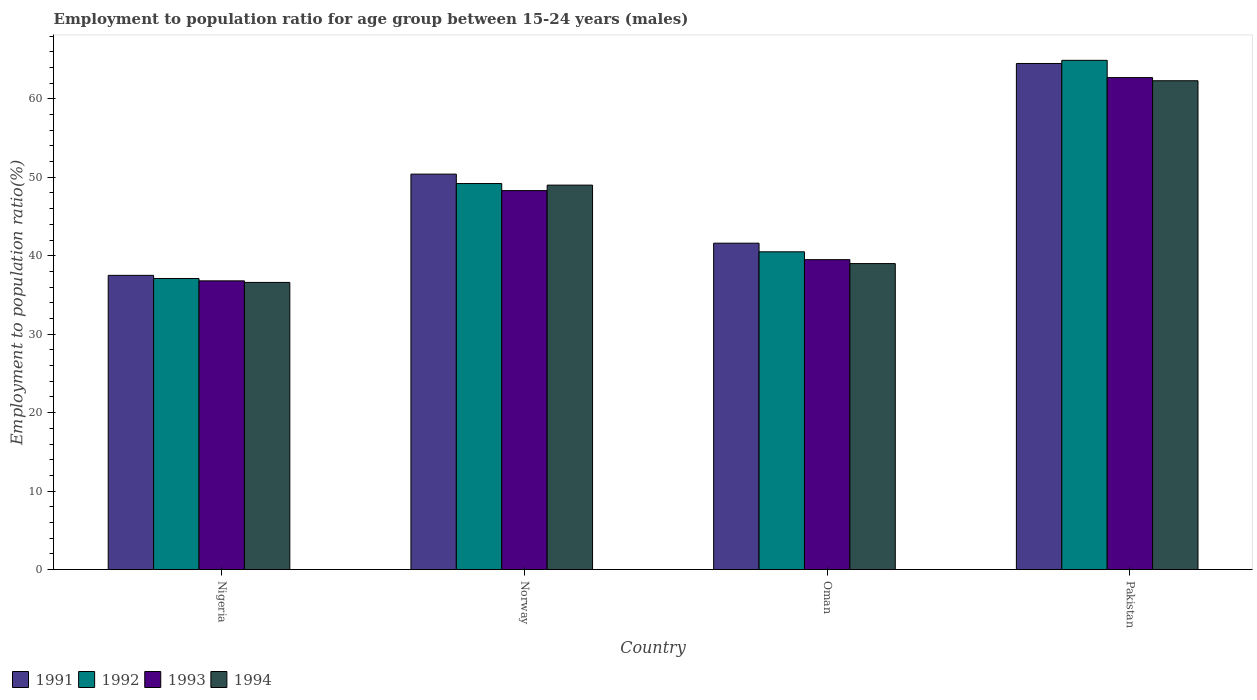How many groups of bars are there?
Your response must be concise. 4. Are the number of bars per tick equal to the number of legend labels?
Provide a succinct answer. Yes. Are the number of bars on each tick of the X-axis equal?
Offer a very short reply. Yes. How many bars are there on the 2nd tick from the left?
Offer a very short reply. 4. How many bars are there on the 3rd tick from the right?
Provide a short and direct response. 4. What is the label of the 3rd group of bars from the left?
Your answer should be compact. Oman. In how many cases, is the number of bars for a given country not equal to the number of legend labels?
Your response must be concise. 0. What is the employment to population ratio in 1991 in Norway?
Your answer should be compact. 50.4. Across all countries, what is the maximum employment to population ratio in 1992?
Your answer should be very brief. 64.9. Across all countries, what is the minimum employment to population ratio in 1991?
Your answer should be very brief. 37.5. In which country was the employment to population ratio in 1991 minimum?
Provide a short and direct response. Nigeria. What is the total employment to population ratio in 1993 in the graph?
Offer a terse response. 187.3. What is the difference between the employment to population ratio in 1992 in Pakistan and the employment to population ratio in 1993 in Oman?
Make the answer very short. 25.4. What is the average employment to population ratio in 1993 per country?
Make the answer very short. 46.82. What is the difference between the employment to population ratio of/in 1994 and employment to population ratio of/in 1993 in Pakistan?
Provide a succinct answer. -0.4. What is the ratio of the employment to population ratio in 1992 in Nigeria to that in Oman?
Provide a short and direct response. 0.92. What is the difference between the highest and the second highest employment to population ratio in 1991?
Provide a short and direct response. 22.9. What is the difference between the highest and the lowest employment to population ratio in 1994?
Give a very brief answer. 25.7. In how many countries, is the employment to population ratio in 1992 greater than the average employment to population ratio in 1992 taken over all countries?
Your answer should be compact. 2. What does the 1st bar from the left in Nigeria represents?
Make the answer very short. 1991. How many bars are there?
Your answer should be compact. 16. Are all the bars in the graph horizontal?
Offer a terse response. No. How many countries are there in the graph?
Your answer should be compact. 4. Are the values on the major ticks of Y-axis written in scientific E-notation?
Ensure brevity in your answer.  No. How are the legend labels stacked?
Provide a short and direct response. Horizontal. What is the title of the graph?
Ensure brevity in your answer.  Employment to population ratio for age group between 15-24 years (males). Does "1999" appear as one of the legend labels in the graph?
Offer a very short reply. No. What is the label or title of the X-axis?
Offer a terse response. Country. What is the Employment to population ratio(%) of 1991 in Nigeria?
Provide a succinct answer. 37.5. What is the Employment to population ratio(%) in 1992 in Nigeria?
Provide a succinct answer. 37.1. What is the Employment to population ratio(%) of 1993 in Nigeria?
Keep it short and to the point. 36.8. What is the Employment to population ratio(%) in 1994 in Nigeria?
Ensure brevity in your answer.  36.6. What is the Employment to population ratio(%) in 1991 in Norway?
Keep it short and to the point. 50.4. What is the Employment to population ratio(%) in 1992 in Norway?
Your answer should be compact. 49.2. What is the Employment to population ratio(%) in 1993 in Norway?
Provide a short and direct response. 48.3. What is the Employment to population ratio(%) in 1991 in Oman?
Provide a short and direct response. 41.6. What is the Employment to population ratio(%) in 1992 in Oman?
Your response must be concise. 40.5. What is the Employment to population ratio(%) of 1993 in Oman?
Give a very brief answer. 39.5. What is the Employment to population ratio(%) in 1991 in Pakistan?
Your answer should be very brief. 64.5. What is the Employment to population ratio(%) in 1992 in Pakistan?
Provide a succinct answer. 64.9. What is the Employment to population ratio(%) in 1993 in Pakistan?
Offer a very short reply. 62.7. What is the Employment to population ratio(%) in 1994 in Pakistan?
Your answer should be compact. 62.3. Across all countries, what is the maximum Employment to population ratio(%) of 1991?
Give a very brief answer. 64.5. Across all countries, what is the maximum Employment to population ratio(%) of 1992?
Make the answer very short. 64.9. Across all countries, what is the maximum Employment to population ratio(%) of 1993?
Your answer should be compact. 62.7. Across all countries, what is the maximum Employment to population ratio(%) in 1994?
Keep it short and to the point. 62.3. Across all countries, what is the minimum Employment to population ratio(%) in 1991?
Keep it short and to the point. 37.5. Across all countries, what is the minimum Employment to population ratio(%) of 1992?
Your answer should be compact. 37.1. Across all countries, what is the minimum Employment to population ratio(%) in 1993?
Offer a terse response. 36.8. Across all countries, what is the minimum Employment to population ratio(%) in 1994?
Your answer should be very brief. 36.6. What is the total Employment to population ratio(%) in 1991 in the graph?
Provide a short and direct response. 194. What is the total Employment to population ratio(%) in 1992 in the graph?
Offer a terse response. 191.7. What is the total Employment to population ratio(%) of 1993 in the graph?
Make the answer very short. 187.3. What is the total Employment to population ratio(%) in 1994 in the graph?
Your response must be concise. 186.9. What is the difference between the Employment to population ratio(%) of 1991 in Nigeria and that in Norway?
Your response must be concise. -12.9. What is the difference between the Employment to population ratio(%) of 1992 in Nigeria and that in Norway?
Offer a very short reply. -12.1. What is the difference between the Employment to population ratio(%) in 1992 in Nigeria and that in Oman?
Offer a terse response. -3.4. What is the difference between the Employment to population ratio(%) of 1992 in Nigeria and that in Pakistan?
Provide a succinct answer. -27.8. What is the difference between the Employment to population ratio(%) of 1993 in Nigeria and that in Pakistan?
Provide a short and direct response. -25.9. What is the difference between the Employment to population ratio(%) in 1994 in Nigeria and that in Pakistan?
Offer a very short reply. -25.7. What is the difference between the Employment to population ratio(%) in 1994 in Norway and that in Oman?
Your answer should be very brief. 10. What is the difference between the Employment to population ratio(%) of 1991 in Norway and that in Pakistan?
Give a very brief answer. -14.1. What is the difference between the Employment to population ratio(%) in 1992 in Norway and that in Pakistan?
Provide a short and direct response. -15.7. What is the difference between the Employment to population ratio(%) in 1993 in Norway and that in Pakistan?
Your answer should be compact. -14.4. What is the difference between the Employment to population ratio(%) of 1991 in Oman and that in Pakistan?
Your answer should be compact. -22.9. What is the difference between the Employment to population ratio(%) in 1992 in Oman and that in Pakistan?
Make the answer very short. -24.4. What is the difference between the Employment to population ratio(%) in 1993 in Oman and that in Pakistan?
Your answer should be compact. -23.2. What is the difference between the Employment to population ratio(%) of 1994 in Oman and that in Pakistan?
Give a very brief answer. -23.3. What is the difference between the Employment to population ratio(%) in 1991 in Nigeria and the Employment to population ratio(%) in 1993 in Oman?
Provide a short and direct response. -2. What is the difference between the Employment to population ratio(%) in 1992 in Nigeria and the Employment to population ratio(%) in 1994 in Oman?
Offer a terse response. -1.9. What is the difference between the Employment to population ratio(%) in 1991 in Nigeria and the Employment to population ratio(%) in 1992 in Pakistan?
Offer a very short reply. -27.4. What is the difference between the Employment to population ratio(%) of 1991 in Nigeria and the Employment to population ratio(%) of 1993 in Pakistan?
Offer a terse response. -25.2. What is the difference between the Employment to population ratio(%) in 1991 in Nigeria and the Employment to population ratio(%) in 1994 in Pakistan?
Offer a terse response. -24.8. What is the difference between the Employment to population ratio(%) of 1992 in Nigeria and the Employment to population ratio(%) of 1993 in Pakistan?
Give a very brief answer. -25.6. What is the difference between the Employment to population ratio(%) of 1992 in Nigeria and the Employment to population ratio(%) of 1994 in Pakistan?
Provide a short and direct response. -25.2. What is the difference between the Employment to population ratio(%) in 1993 in Nigeria and the Employment to population ratio(%) in 1994 in Pakistan?
Offer a very short reply. -25.5. What is the difference between the Employment to population ratio(%) in 1991 in Norway and the Employment to population ratio(%) in 1992 in Oman?
Offer a very short reply. 9.9. What is the difference between the Employment to population ratio(%) of 1991 in Norway and the Employment to population ratio(%) of 1993 in Oman?
Offer a terse response. 10.9. What is the difference between the Employment to population ratio(%) in 1992 in Norway and the Employment to population ratio(%) in 1994 in Oman?
Make the answer very short. 10.2. What is the difference between the Employment to population ratio(%) in 1991 in Norway and the Employment to population ratio(%) in 1994 in Pakistan?
Give a very brief answer. -11.9. What is the difference between the Employment to population ratio(%) of 1992 in Norway and the Employment to population ratio(%) of 1993 in Pakistan?
Your answer should be compact. -13.5. What is the difference between the Employment to population ratio(%) of 1991 in Oman and the Employment to population ratio(%) of 1992 in Pakistan?
Give a very brief answer. -23.3. What is the difference between the Employment to population ratio(%) of 1991 in Oman and the Employment to population ratio(%) of 1993 in Pakistan?
Provide a short and direct response. -21.1. What is the difference between the Employment to population ratio(%) of 1991 in Oman and the Employment to population ratio(%) of 1994 in Pakistan?
Make the answer very short. -20.7. What is the difference between the Employment to population ratio(%) in 1992 in Oman and the Employment to population ratio(%) in 1993 in Pakistan?
Provide a short and direct response. -22.2. What is the difference between the Employment to population ratio(%) in 1992 in Oman and the Employment to population ratio(%) in 1994 in Pakistan?
Provide a short and direct response. -21.8. What is the difference between the Employment to population ratio(%) in 1993 in Oman and the Employment to population ratio(%) in 1994 in Pakistan?
Offer a terse response. -22.8. What is the average Employment to population ratio(%) of 1991 per country?
Provide a short and direct response. 48.5. What is the average Employment to population ratio(%) in 1992 per country?
Your response must be concise. 47.92. What is the average Employment to population ratio(%) in 1993 per country?
Your response must be concise. 46.83. What is the average Employment to population ratio(%) of 1994 per country?
Give a very brief answer. 46.73. What is the difference between the Employment to population ratio(%) in 1991 and Employment to population ratio(%) in 1992 in Nigeria?
Your response must be concise. 0.4. What is the difference between the Employment to population ratio(%) in 1991 and Employment to population ratio(%) in 1993 in Nigeria?
Make the answer very short. 0.7. What is the difference between the Employment to population ratio(%) in 1991 and Employment to population ratio(%) in 1994 in Nigeria?
Give a very brief answer. 0.9. What is the difference between the Employment to population ratio(%) in 1993 and Employment to population ratio(%) in 1994 in Nigeria?
Provide a succinct answer. 0.2. What is the difference between the Employment to population ratio(%) of 1991 and Employment to population ratio(%) of 1992 in Norway?
Provide a succinct answer. 1.2. What is the difference between the Employment to population ratio(%) in 1991 and Employment to population ratio(%) in 1993 in Norway?
Offer a very short reply. 2.1. What is the difference between the Employment to population ratio(%) in 1991 and Employment to population ratio(%) in 1994 in Norway?
Your answer should be very brief. 1.4. What is the difference between the Employment to population ratio(%) in 1992 and Employment to population ratio(%) in 1993 in Norway?
Ensure brevity in your answer.  0.9. What is the difference between the Employment to population ratio(%) in 1991 and Employment to population ratio(%) in 1994 in Oman?
Your response must be concise. 2.6. What is the difference between the Employment to population ratio(%) of 1992 and Employment to population ratio(%) of 1994 in Oman?
Keep it short and to the point. 1.5. What is the difference between the Employment to population ratio(%) of 1991 and Employment to population ratio(%) of 1993 in Pakistan?
Keep it short and to the point. 1.8. What is the difference between the Employment to population ratio(%) in 1991 and Employment to population ratio(%) in 1994 in Pakistan?
Offer a very short reply. 2.2. What is the difference between the Employment to population ratio(%) of 1992 and Employment to population ratio(%) of 1993 in Pakistan?
Provide a succinct answer. 2.2. What is the ratio of the Employment to population ratio(%) of 1991 in Nigeria to that in Norway?
Give a very brief answer. 0.74. What is the ratio of the Employment to population ratio(%) of 1992 in Nigeria to that in Norway?
Make the answer very short. 0.75. What is the ratio of the Employment to population ratio(%) of 1993 in Nigeria to that in Norway?
Give a very brief answer. 0.76. What is the ratio of the Employment to population ratio(%) in 1994 in Nigeria to that in Norway?
Offer a terse response. 0.75. What is the ratio of the Employment to population ratio(%) in 1991 in Nigeria to that in Oman?
Give a very brief answer. 0.9. What is the ratio of the Employment to population ratio(%) of 1992 in Nigeria to that in Oman?
Provide a short and direct response. 0.92. What is the ratio of the Employment to population ratio(%) of 1993 in Nigeria to that in Oman?
Ensure brevity in your answer.  0.93. What is the ratio of the Employment to population ratio(%) of 1994 in Nigeria to that in Oman?
Keep it short and to the point. 0.94. What is the ratio of the Employment to population ratio(%) of 1991 in Nigeria to that in Pakistan?
Your answer should be compact. 0.58. What is the ratio of the Employment to population ratio(%) in 1992 in Nigeria to that in Pakistan?
Your response must be concise. 0.57. What is the ratio of the Employment to population ratio(%) of 1993 in Nigeria to that in Pakistan?
Ensure brevity in your answer.  0.59. What is the ratio of the Employment to population ratio(%) of 1994 in Nigeria to that in Pakistan?
Make the answer very short. 0.59. What is the ratio of the Employment to population ratio(%) of 1991 in Norway to that in Oman?
Make the answer very short. 1.21. What is the ratio of the Employment to population ratio(%) of 1992 in Norway to that in Oman?
Offer a very short reply. 1.21. What is the ratio of the Employment to population ratio(%) in 1993 in Norway to that in Oman?
Offer a terse response. 1.22. What is the ratio of the Employment to population ratio(%) of 1994 in Norway to that in Oman?
Your answer should be compact. 1.26. What is the ratio of the Employment to population ratio(%) in 1991 in Norway to that in Pakistan?
Provide a short and direct response. 0.78. What is the ratio of the Employment to population ratio(%) in 1992 in Norway to that in Pakistan?
Offer a very short reply. 0.76. What is the ratio of the Employment to population ratio(%) of 1993 in Norway to that in Pakistan?
Offer a very short reply. 0.77. What is the ratio of the Employment to population ratio(%) of 1994 in Norway to that in Pakistan?
Make the answer very short. 0.79. What is the ratio of the Employment to population ratio(%) in 1991 in Oman to that in Pakistan?
Your answer should be compact. 0.65. What is the ratio of the Employment to population ratio(%) in 1992 in Oman to that in Pakistan?
Provide a short and direct response. 0.62. What is the ratio of the Employment to population ratio(%) in 1993 in Oman to that in Pakistan?
Give a very brief answer. 0.63. What is the ratio of the Employment to population ratio(%) of 1994 in Oman to that in Pakistan?
Keep it short and to the point. 0.63. What is the difference between the highest and the second highest Employment to population ratio(%) in 1991?
Make the answer very short. 14.1. What is the difference between the highest and the second highest Employment to population ratio(%) of 1993?
Give a very brief answer. 14.4. What is the difference between the highest and the lowest Employment to population ratio(%) of 1991?
Your answer should be compact. 27. What is the difference between the highest and the lowest Employment to population ratio(%) of 1992?
Make the answer very short. 27.8. What is the difference between the highest and the lowest Employment to population ratio(%) in 1993?
Keep it short and to the point. 25.9. What is the difference between the highest and the lowest Employment to population ratio(%) in 1994?
Offer a very short reply. 25.7. 